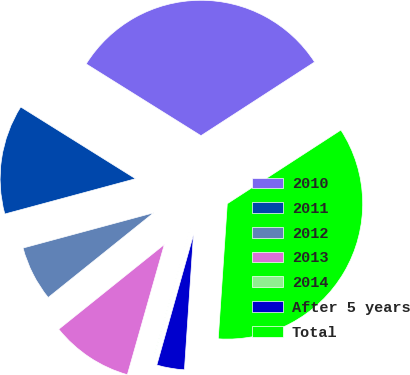<chart> <loc_0><loc_0><loc_500><loc_500><pie_chart><fcel>2010<fcel>2011<fcel>2012<fcel>2013<fcel>2014<fcel>After 5 years<fcel>Total<nl><fcel>31.95%<fcel>13.09%<fcel>6.57%<fcel>9.83%<fcel>0.04%<fcel>3.3%<fcel>35.22%<nl></chart> 